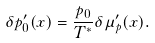Convert formula to latex. <formula><loc_0><loc_0><loc_500><loc_500>\delta p _ { 0 } ^ { \prime } ( x ) = \frac { p _ { 0 } } { T ^ { * } } \delta \mu _ { p } ^ { \prime } ( x ) .</formula> 